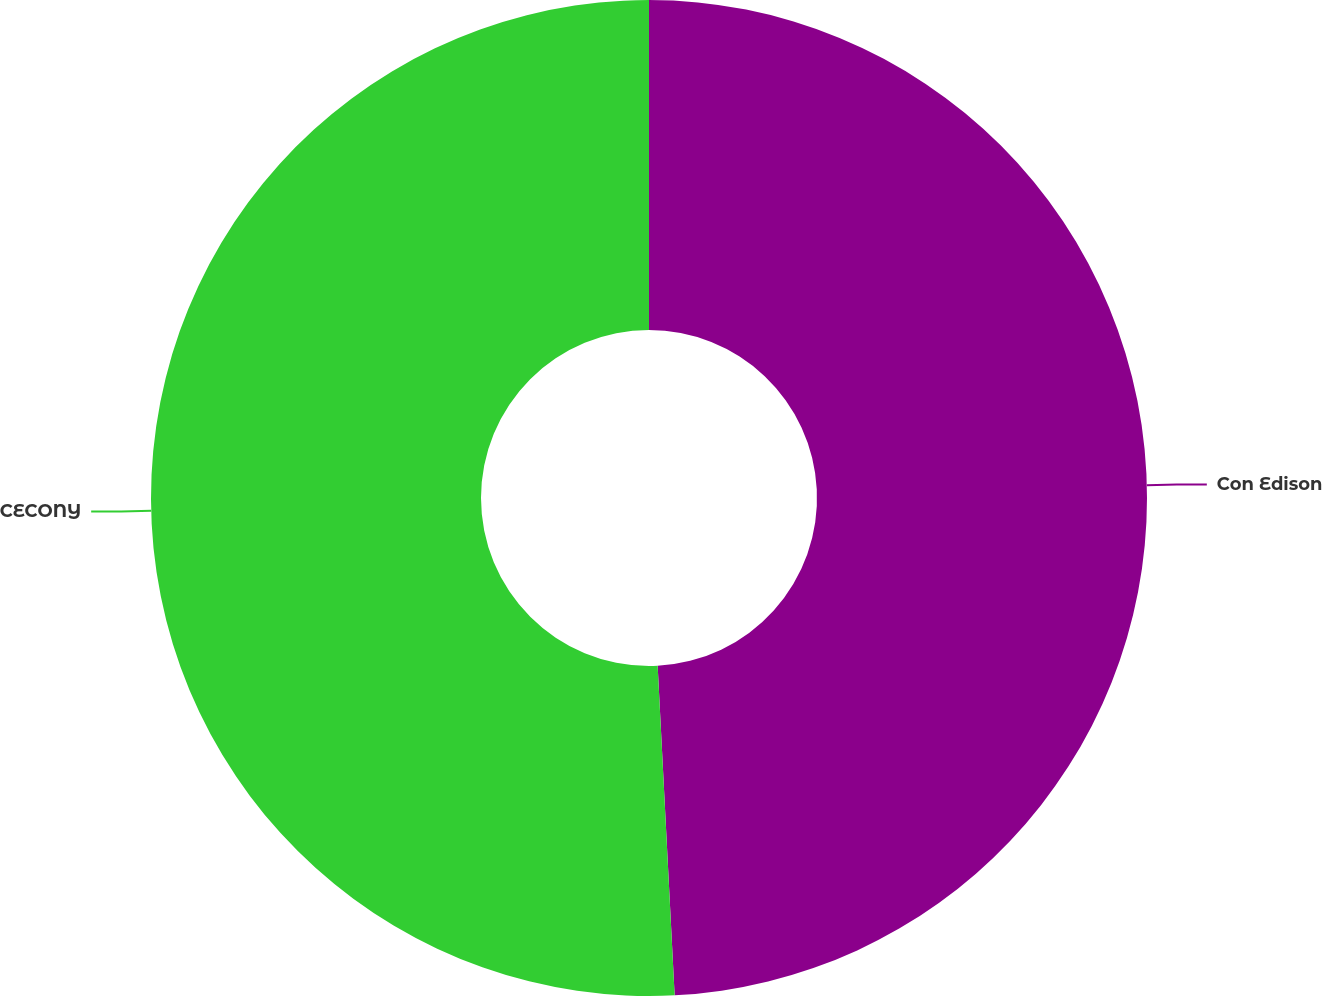<chart> <loc_0><loc_0><loc_500><loc_500><pie_chart><fcel>Con Edison<fcel>CECONY<nl><fcel>49.18%<fcel>50.82%<nl></chart> 